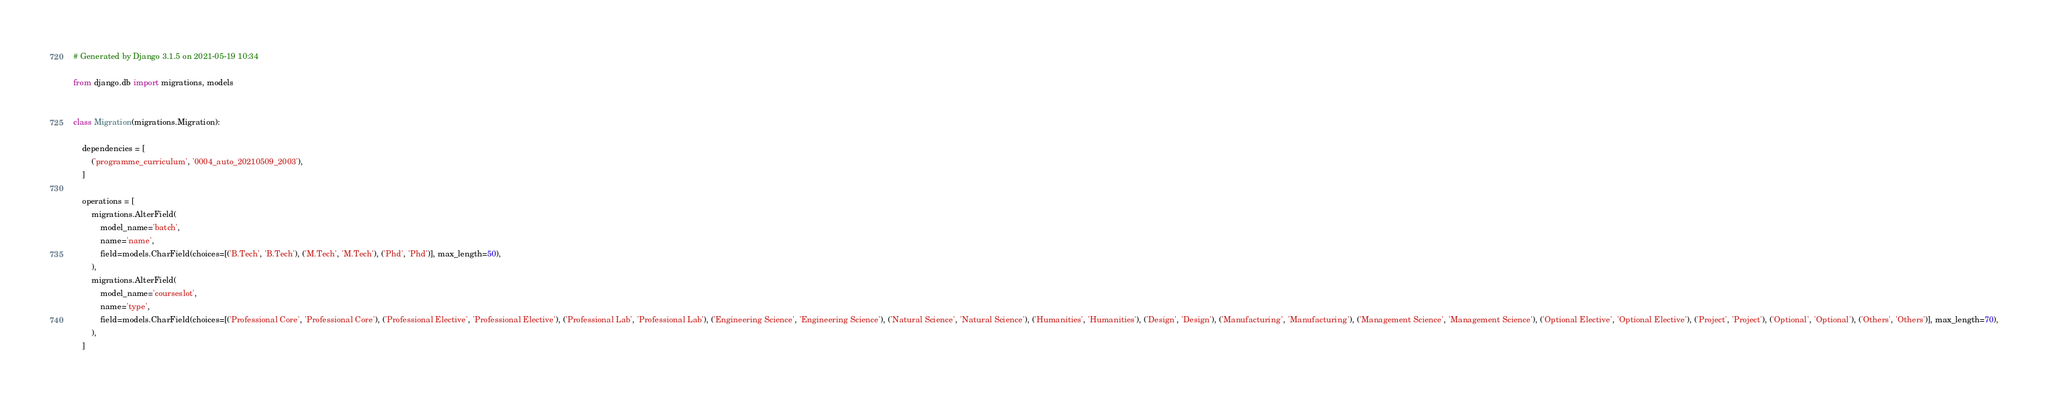<code> <loc_0><loc_0><loc_500><loc_500><_Python_># Generated by Django 3.1.5 on 2021-05-19 10:34

from django.db import migrations, models


class Migration(migrations.Migration):

    dependencies = [
        ('programme_curriculum', '0004_auto_20210509_2003'),
    ]

    operations = [
        migrations.AlterField(
            model_name='batch',
            name='name',
            field=models.CharField(choices=[('B.Tech', 'B.Tech'), ('M.Tech', 'M.Tech'), ('Phd', 'Phd')], max_length=50),
        ),
        migrations.AlterField(
            model_name='courseslot',
            name='type',
            field=models.CharField(choices=[('Professional Core', 'Professional Core'), ('Professional Elective', 'Professional Elective'), ('Professional Lab', 'Professional Lab'), ('Engineering Science', 'Engineering Science'), ('Natural Science', 'Natural Science'), ('Humanities', 'Humanities'), ('Design', 'Design'), ('Manufacturing', 'Manufacturing'), ('Management Science', 'Management Science'), ('Optional Elective', 'Optional Elective'), ('Project', 'Project'), ('Optional', 'Optional'), ('Others', 'Others')], max_length=70),
        ),
    ]
</code> 